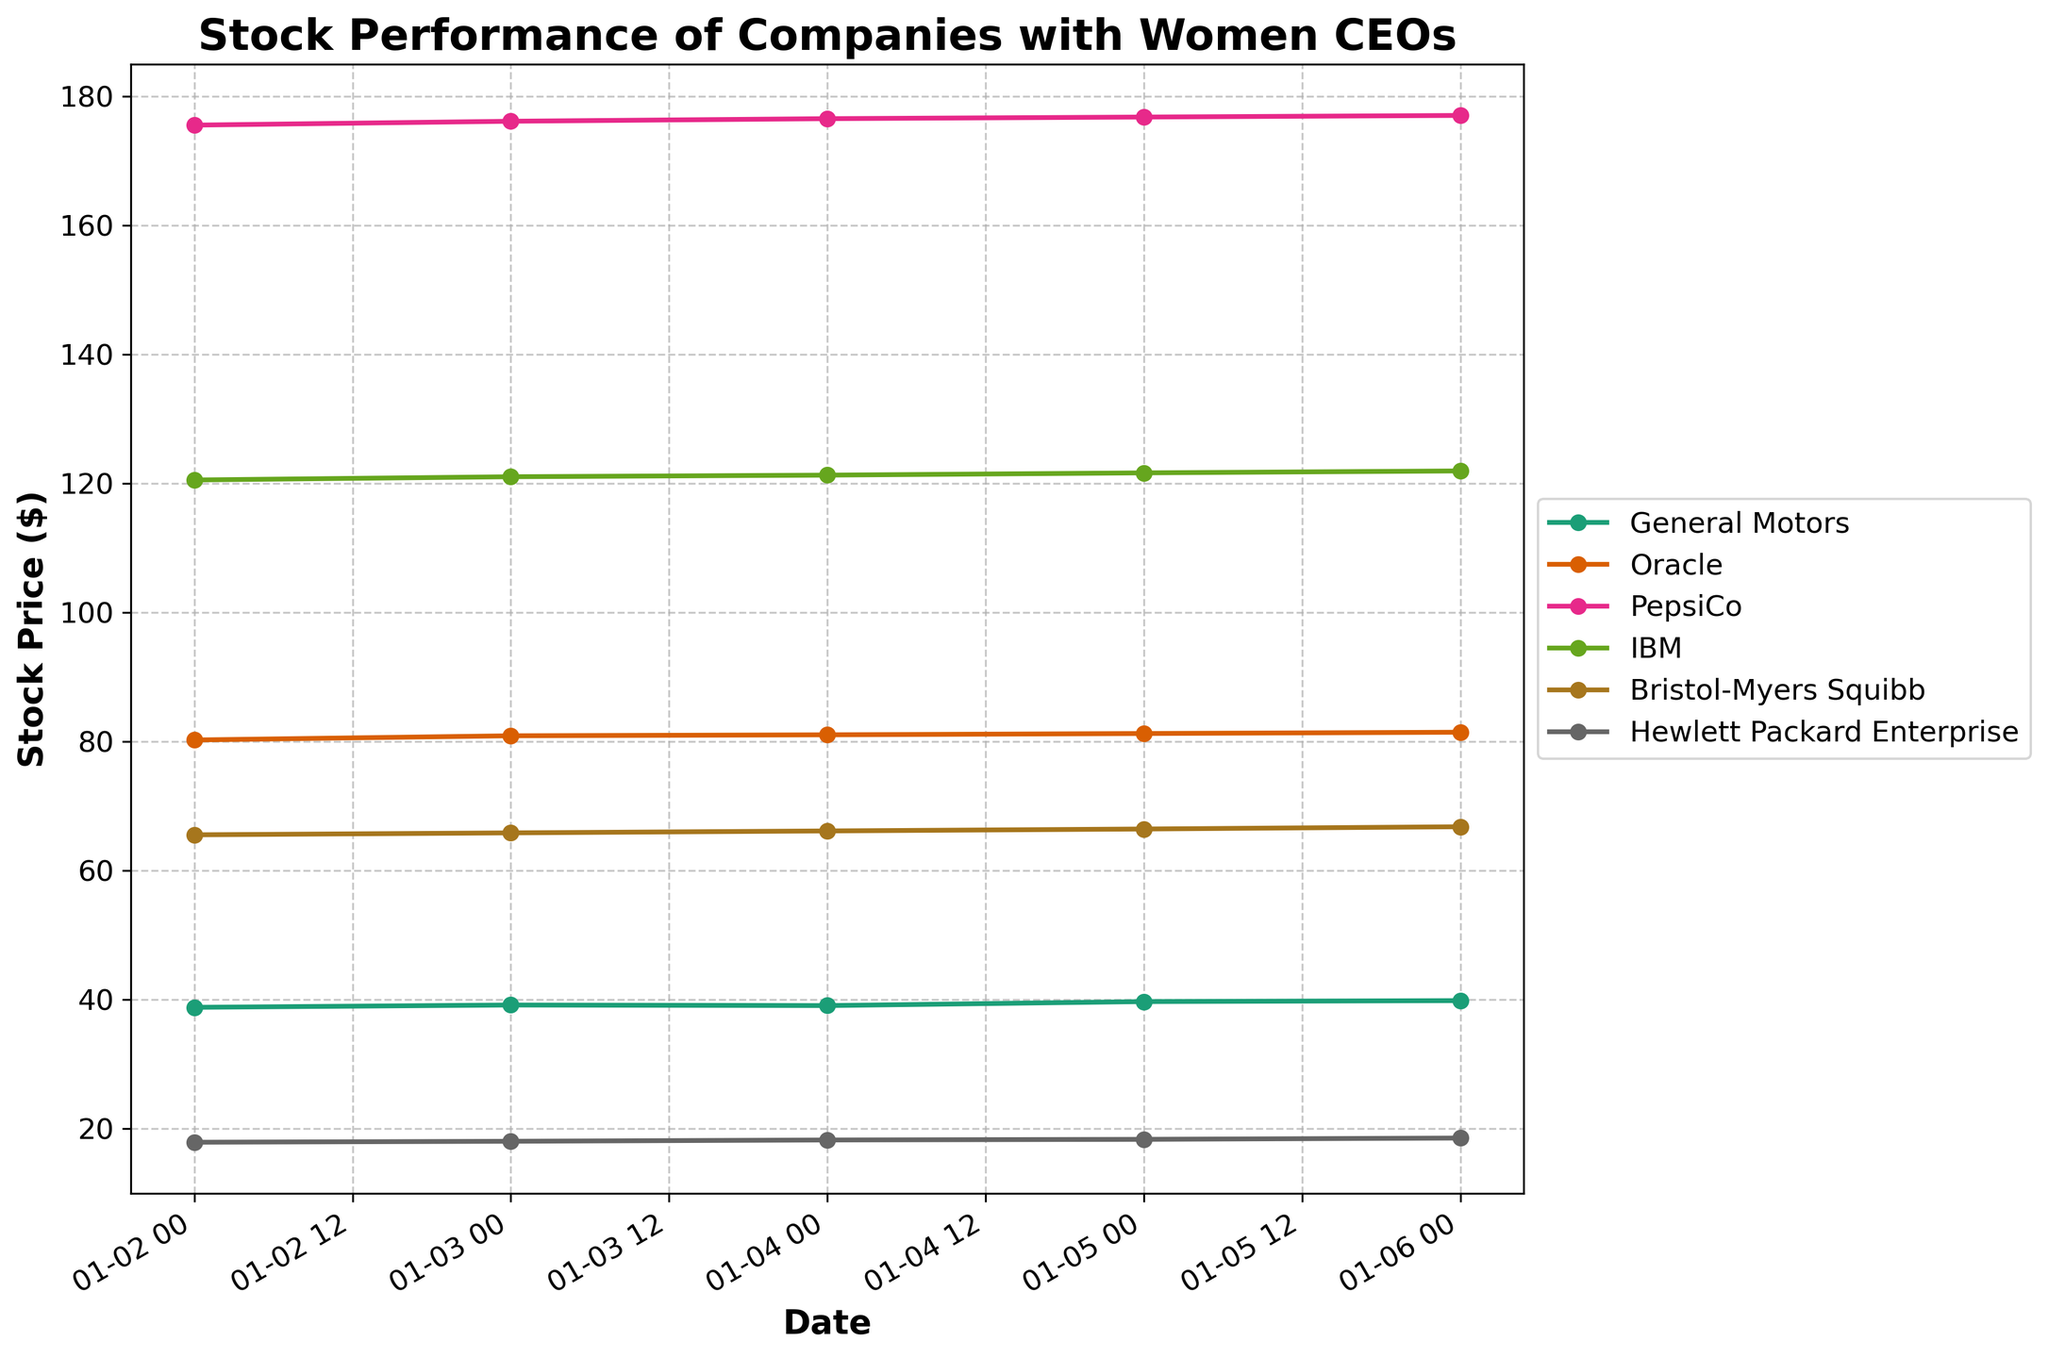What is the title of the plot? The title of the plot is shown at the top of the figure.
Answer: Stock Performance of Companies with Women CEOs What is the stock price of IBM on January 6, 2023? Locate the line corresponding to IBM, then find the data point on January 6, 2023. The stock price is labeled at this point.
Answer: 121.90 Which company had the highest stock price on January 4, 2023? Compare the stock prices of all companies on January 4, 2023. Identify the highest value and its corresponding company.
Answer: PepsiCo How did the stock price of Oracle change from January 3, 2023, to January 6, 2023? Find the stock prices of Oracle on January 3, 2023, and January 6, 2023. Calculate the difference between these prices.
Answer: Increased by 0.55 Which company had the smallest increase in stock price over the time period shown? Calculate the increase in stock price for each company from January 2, 2023, to January 6, 2023, and identify the smallest increase.
Answer: IBM What is the average stock price of General Motors over the dates provided? Add up all the stock prices of General Motors and divide by the number of data points. (38.76 + 39.12 + 39.03 + 39.65 + 39.80) / 5
Answer: 39.272 Which company showed the most consistent (least variable) stock prices during the observed period? Evaluate the variations in stock prices for each company by checking changes day-to-day.
Answer: Hewlett Packard Enterprise Did any company experience a decline in stock price over the plotted period? Check the first and last data points for each company to see if any company’s stock price decreased from January 2, 2023, to January 6, 2023.
Answer: No On which date did Hewlett Packard Enterprise reach its highest stock price? Locate the highest data point on the Hewlett Packard Enterprise line and find the corresponding date.
Answer: January 6, 2023 Which company's stock price increased the most from January 2, 2023, to January 3, 2023? Calculate the price change for each company from January 2, 2023, to January 3, 2023, and find the highest increase.
Answer: Oracle 